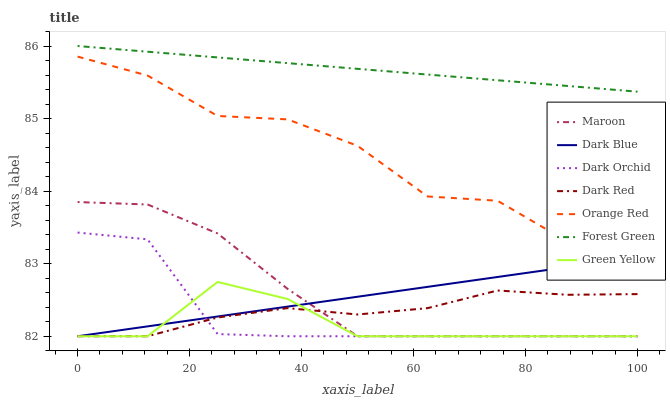Does Dark Orchid have the minimum area under the curve?
Answer yes or no. No. Does Dark Orchid have the maximum area under the curve?
Answer yes or no. No. Is Dark Orchid the smoothest?
Answer yes or no. No. Is Dark Orchid the roughest?
Answer yes or no. No. Does Forest Green have the lowest value?
Answer yes or no. No. Does Dark Orchid have the highest value?
Answer yes or no. No. Is Green Yellow less than Orange Red?
Answer yes or no. Yes. Is Orange Red greater than Dark Red?
Answer yes or no. Yes. Does Green Yellow intersect Orange Red?
Answer yes or no. No. 